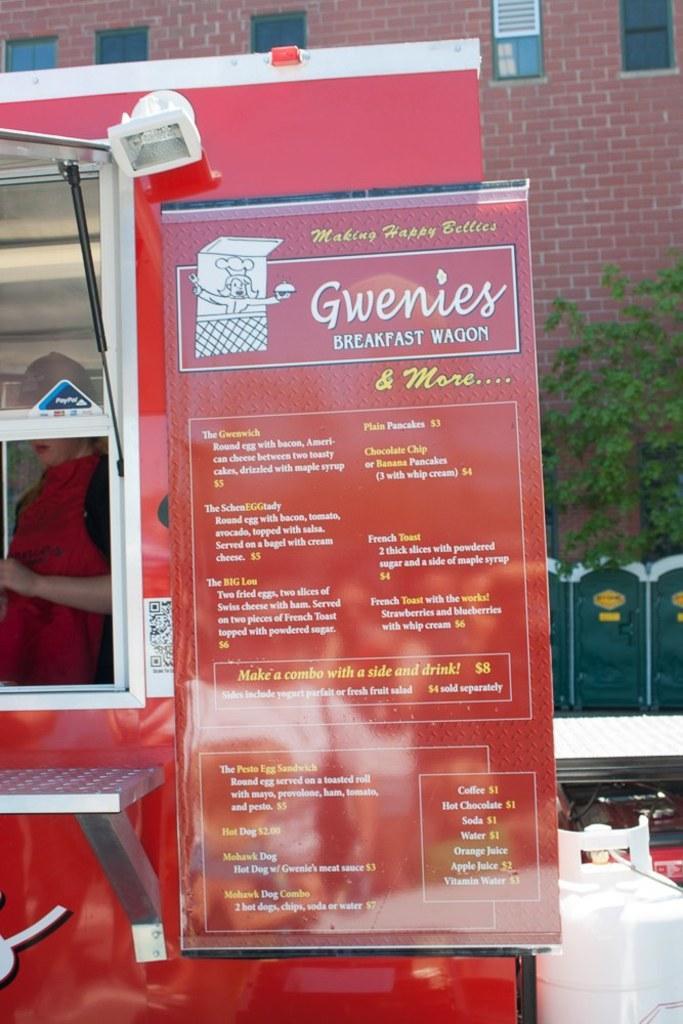Can you describe this image briefly? As we can see in the image there is a banner, vehicle, trees, building and windows. 